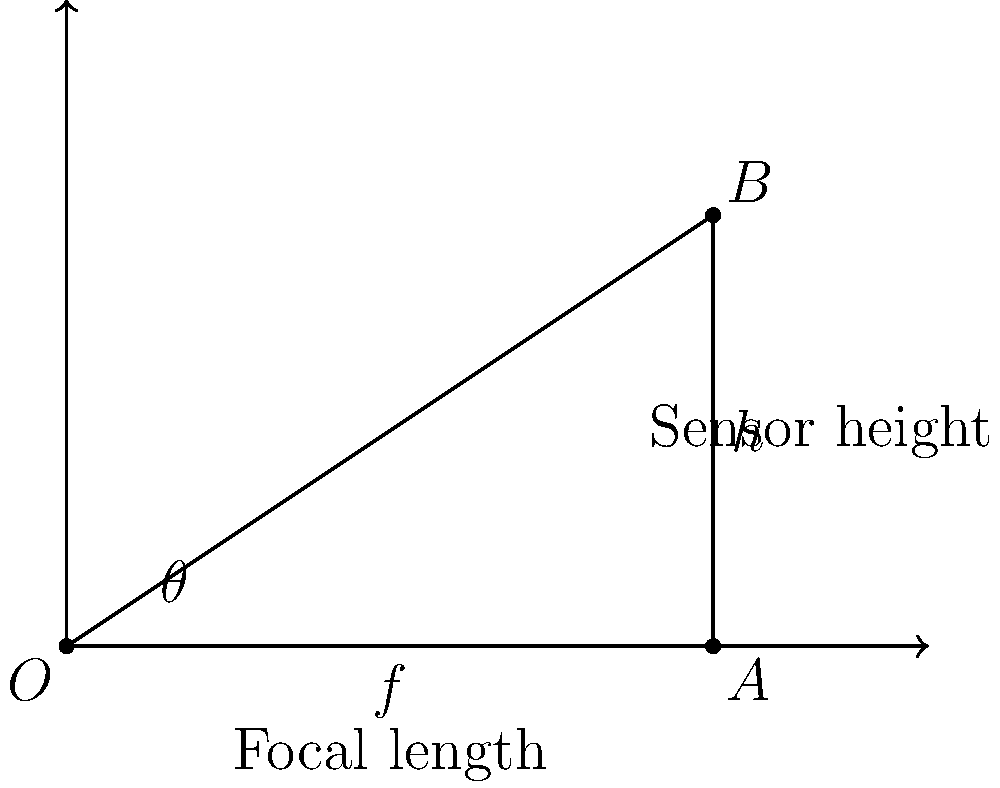A landscape photographer is using a wide-angle lens with a focal length of 24mm on a full-frame camera with a sensor height of 24mm. Using the diagram provided, calculate the vertical angle of view ($\theta$) for this lens setup. To calculate the vertical angle of view for a wide-angle lens, we can use the following steps:

1. Identify the relevant information:
   - Focal length ($f$) = 24mm
   - Sensor height ($h$) = 24mm

2. The diagram shows a right-angled triangle formed by the focal length and half of the sensor height.

3. We can use the arctangent function to find half of the angle of view:
   $$\frac{\theta}{2} = \arctan(\frac{h/2}{f})$$

4. Substitute the values:
   $$\frac{\theta}{2} = \arctan(\frac{24/2}{24}) = \arctan(\frac{12}{24}) = \arctan(0.5)$$

5. Calculate the result:
   $$\frac{\theta}{2} = 26.57°$$

6. Multiply by 2 to get the full vertical angle of view:
   $$\theta = 2 * 26.57° = 53.14°$$

Therefore, the vertical angle of view for this wide-angle lens setup is approximately 53.14°.
Answer: $53.14°$ 